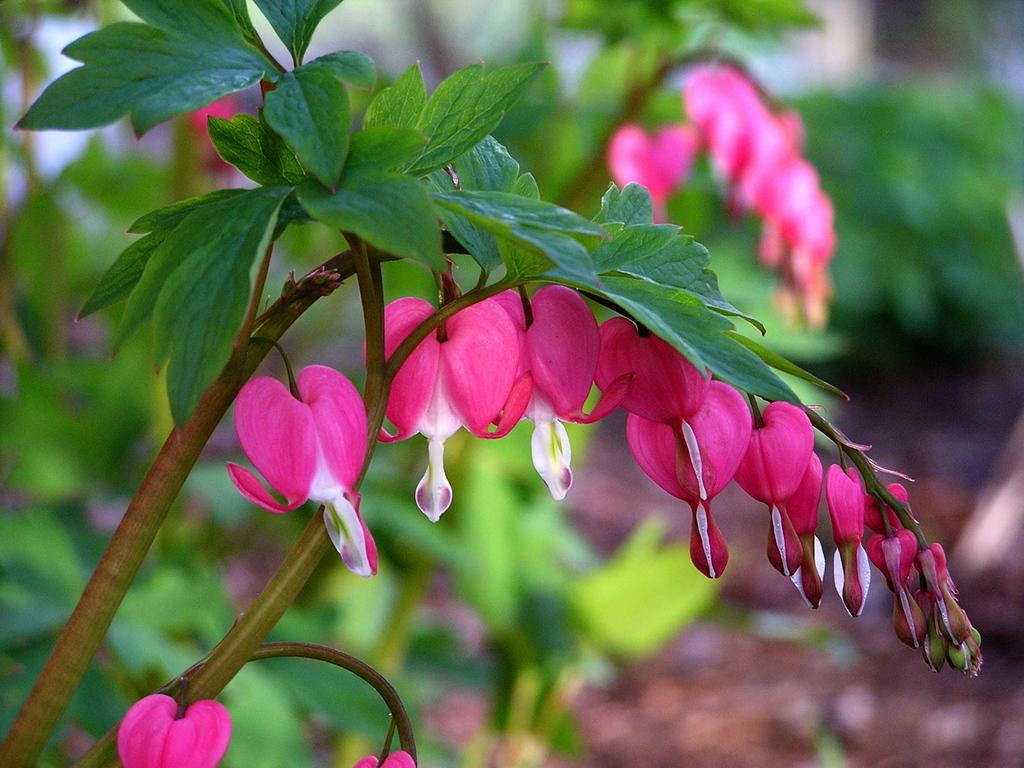What is the main object in the image? There is a tree in the image. What colors can be seen on the tree? The tree has green and brown colors. What additional features are present on the tree? There are flowers on the tree. What colors can be seen on the flowers? The flowers have pink and white colors. What can be seen in the background of the image? There are trees and the ground visible in the background of the image. Where is the toy located in the image? There is no toy present in the image. What type of comfort can be found in the image? The image does not depict any comfort or comforting objects. 